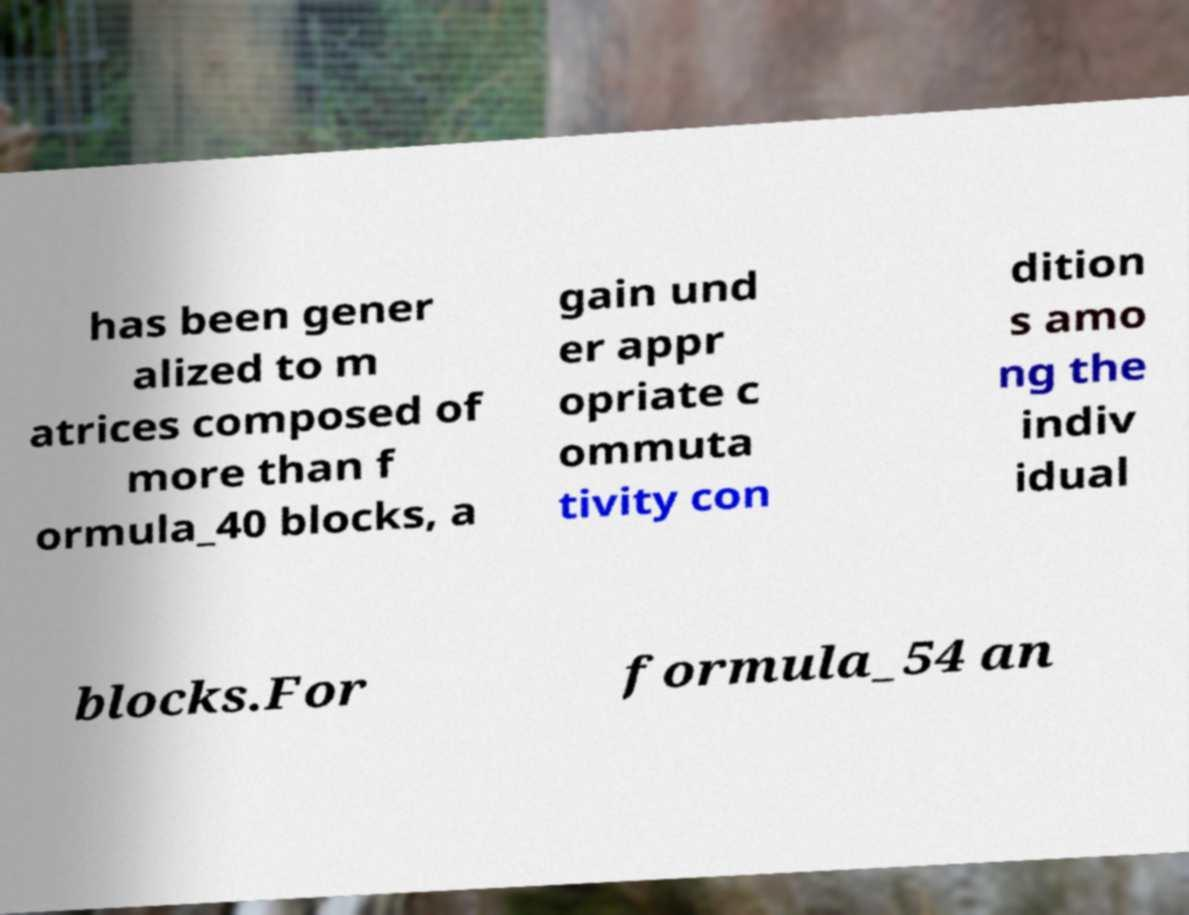What messages or text are displayed in this image? I need them in a readable, typed format. has been gener alized to m atrices composed of more than f ormula_40 blocks, a gain und er appr opriate c ommuta tivity con dition s amo ng the indiv idual blocks.For formula_54 an 